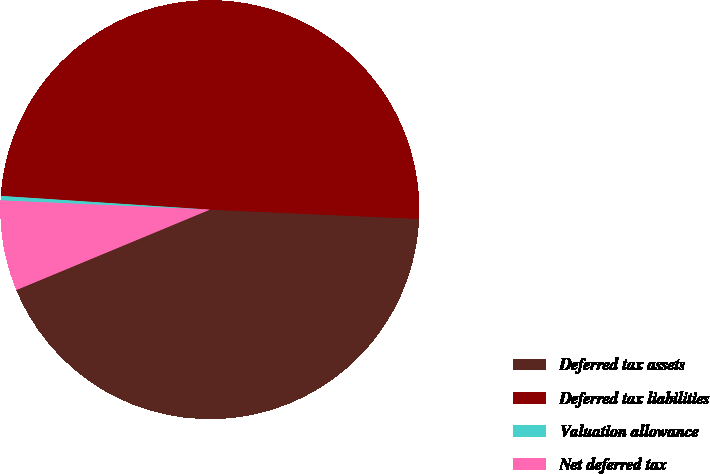Convert chart. <chart><loc_0><loc_0><loc_500><loc_500><pie_chart><fcel>Deferred tax assets<fcel>Deferred tax liabilities<fcel>Valuation allowance<fcel>Net deferred tax<nl><fcel>43.03%<fcel>49.66%<fcel>0.34%<fcel>6.97%<nl></chart> 